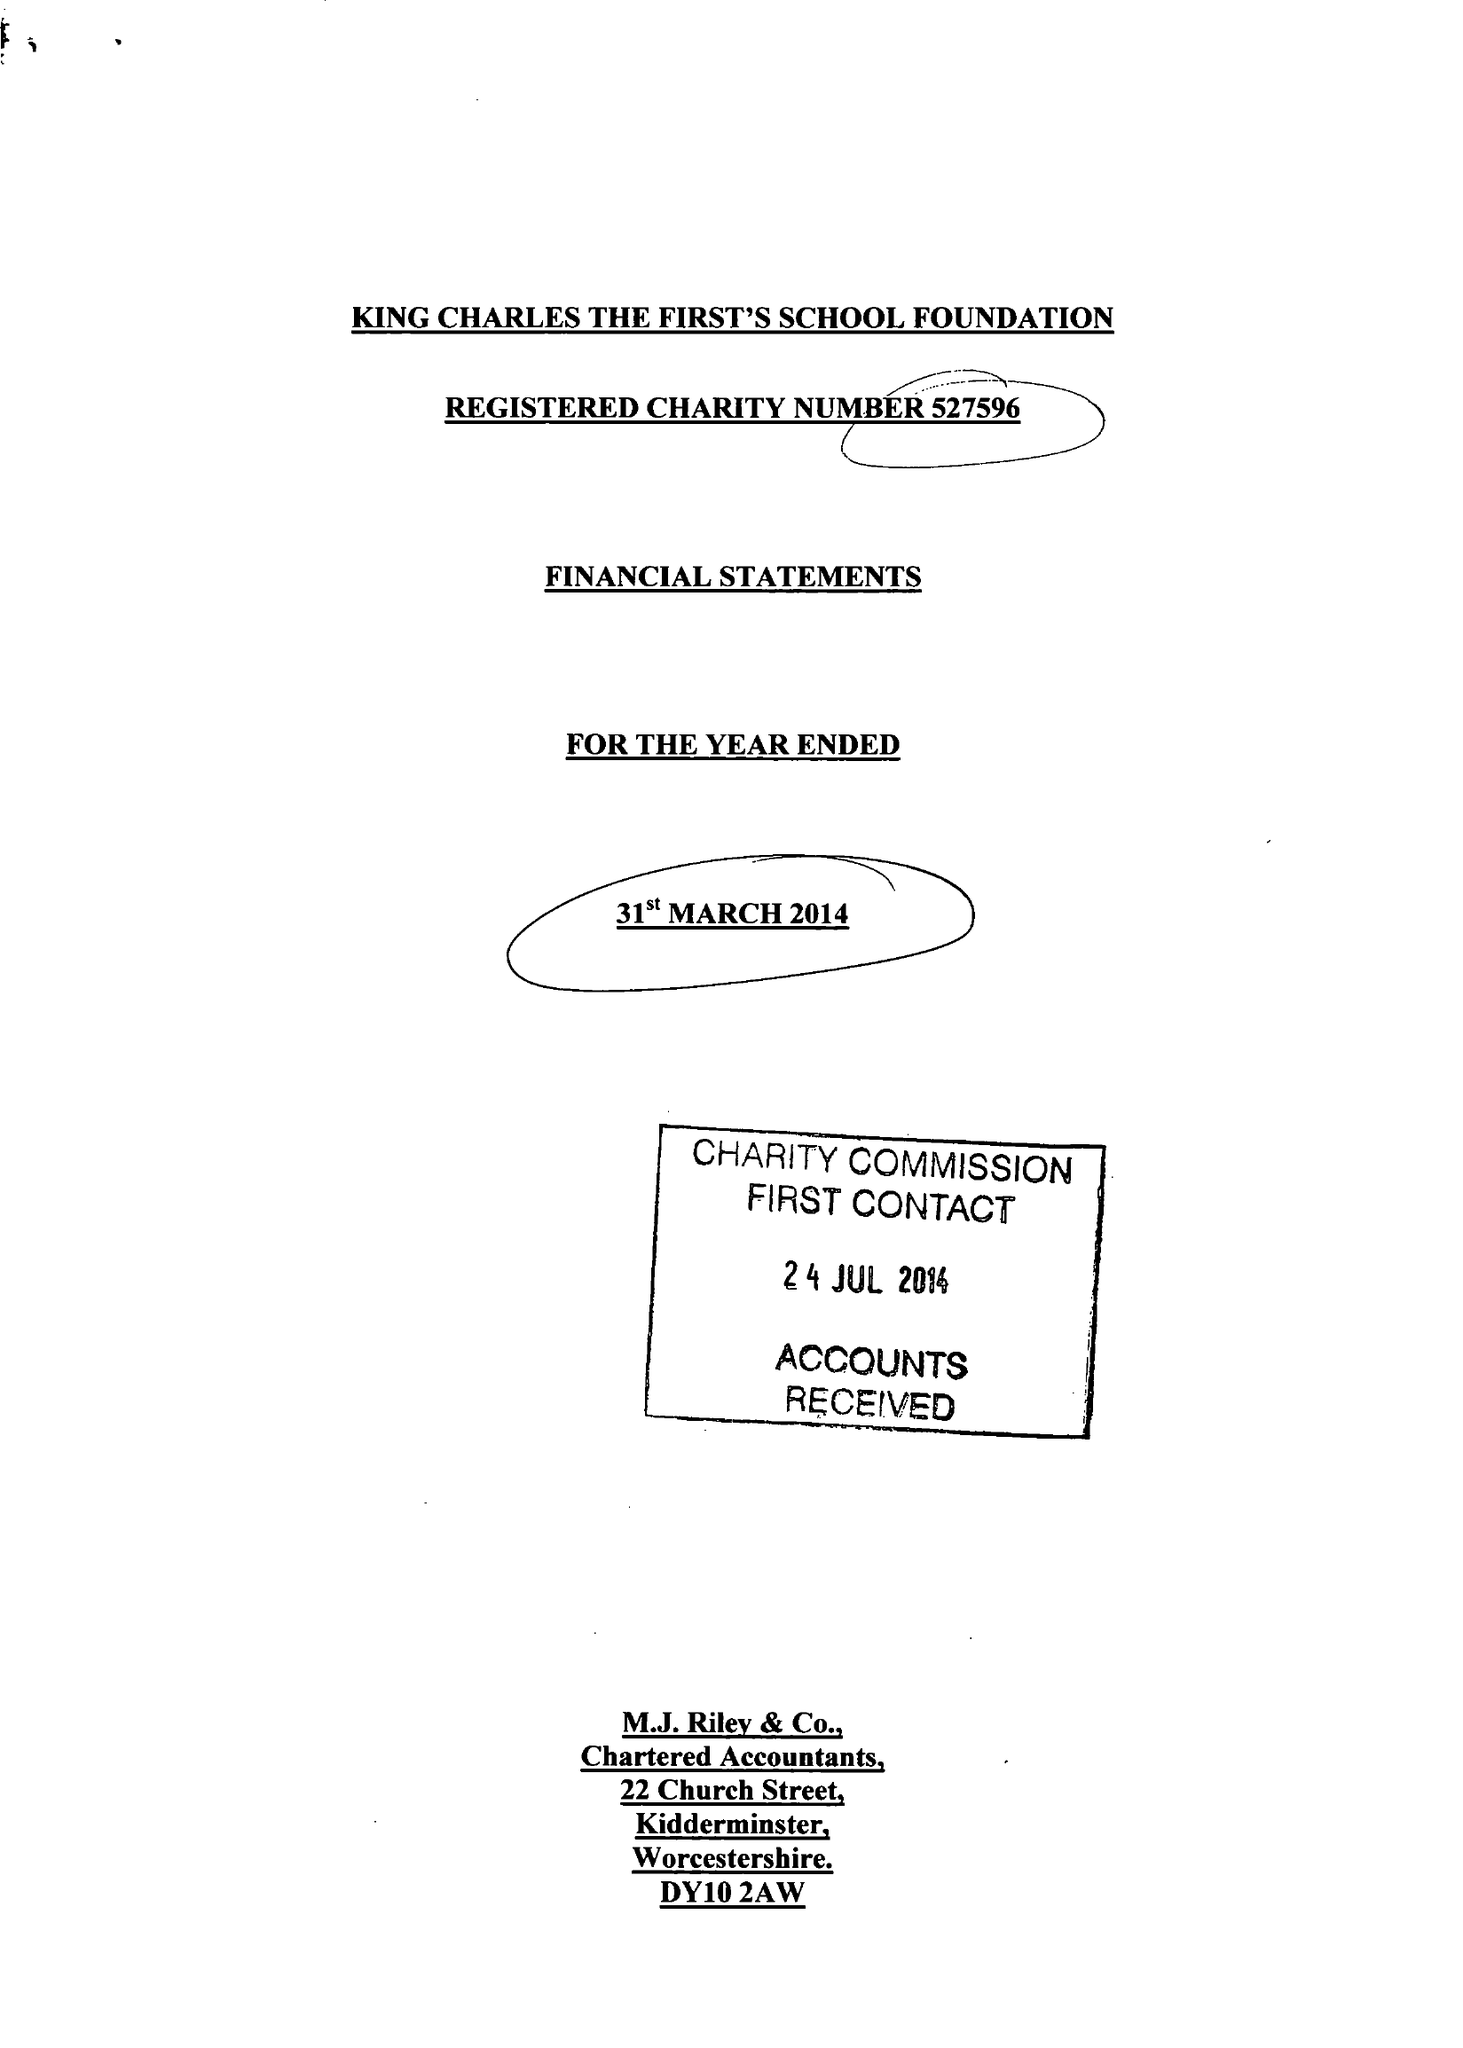What is the value for the income_annually_in_british_pounds?
Answer the question using a single word or phrase. 64671.00 